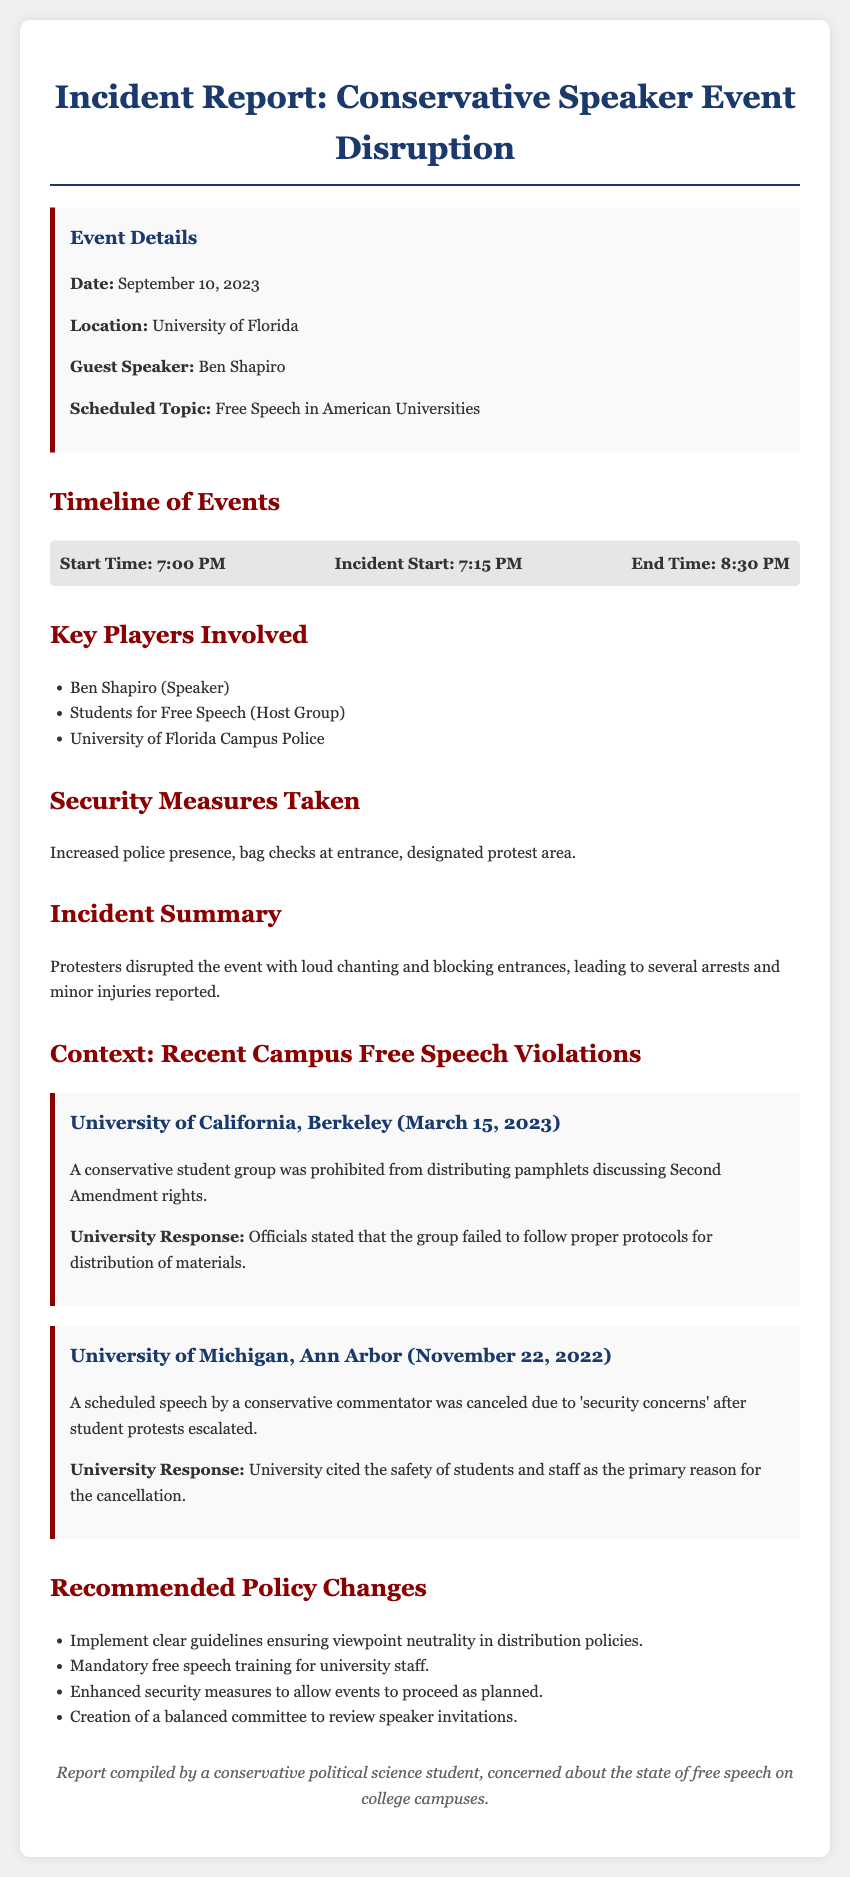what is the date of the event? The date of the event is mentioned in the document, which states that it occurred on September 10, 2023.
Answer: September 10, 2023 who was the guest speaker? The document specifies that the guest speaker for the event was Ben Shapiro.
Answer: Ben Shapiro what university hosted the event? The incident report indicates that the University of Florida hosted the event.
Answer: University of Florida what time did the incident start? The timeline in the document shows that the incident started at 7:15 PM.
Answer: 7:15 PM how many key players are listed? In the document, there are three key players involved, and they are detailed in a list.
Answer: Three which conservative group was mentioned in the report? The document identifies "Students for Free Speech" as the host group for the event.
Answer: Students for Free Speech what security measure was implemented? The incident report notes that there was an increased police presence as a security measure taken at the event.
Answer: Increased police presence what incident occurred at UC Berkeley? The document reports that a conservative student group was prohibited from distributing pamphlets discussing Second Amendment rights.
Answer: Prohibited from distributing pamphlets what is one recommended policy change? The document lists multiple recommended policy changes, one being implementing clear guidelines ensuring viewpoint neutrality.
Answer: Clear guidelines ensuring viewpoint neutrality 